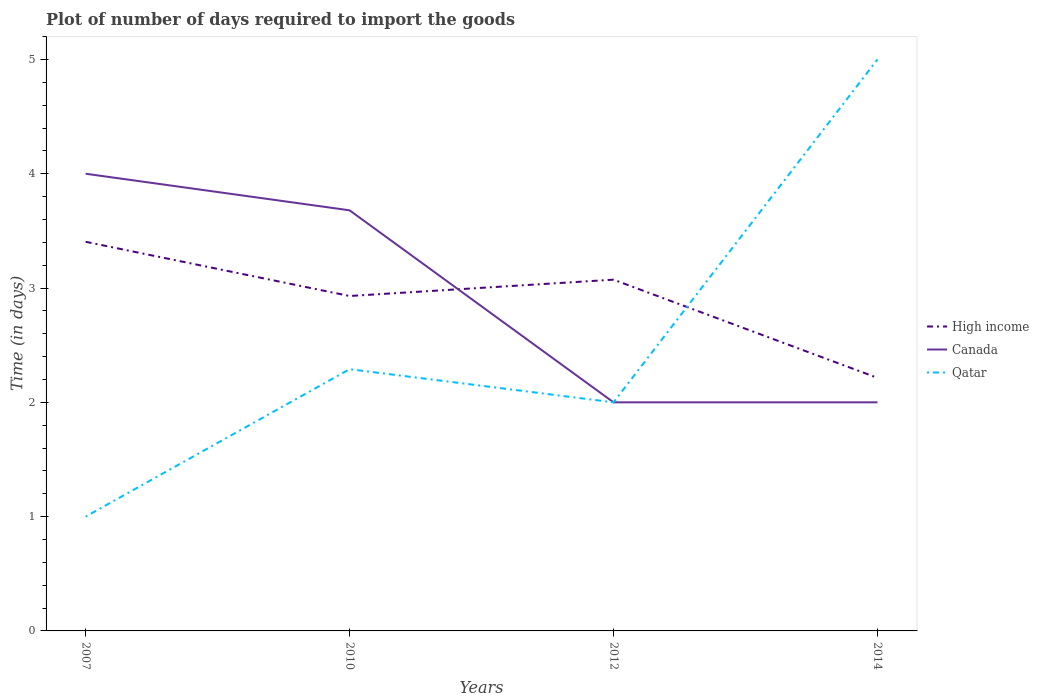Is the number of lines equal to the number of legend labels?
Provide a short and direct response. Yes. In which year was the time required to import goods in Qatar maximum?
Your answer should be compact. 2007. What is the total time required to import goods in Qatar in the graph?
Your response must be concise. -1.29. How many years are there in the graph?
Provide a succinct answer. 4. Does the graph contain grids?
Make the answer very short. No. Where does the legend appear in the graph?
Offer a terse response. Center right. How many legend labels are there?
Make the answer very short. 3. What is the title of the graph?
Give a very brief answer. Plot of number of days required to import the goods. What is the label or title of the X-axis?
Your answer should be compact. Years. What is the label or title of the Y-axis?
Make the answer very short. Time (in days). What is the Time (in days) in High income in 2007?
Provide a succinct answer. 3.4. What is the Time (in days) of Canada in 2007?
Offer a very short reply. 4. What is the Time (in days) in Qatar in 2007?
Offer a terse response. 1. What is the Time (in days) of High income in 2010?
Your response must be concise. 2.93. What is the Time (in days) in Canada in 2010?
Give a very brief answer. 3.68. What is the Time (in days) of Qatar in 2010?
Offer a very short reply. 2.29. What is the Time (in days) of High income in 2012?
Your response must be concise. 3.07. What is the Time (in days) in Canada in 2012?
Provide a short and direct response. 2. What is the Time (in days) in Qatar in 2012?
Provide a succinct answer. 2. What is the Time (in days) in High income in 2014?
Provide a short and direct response. 2.21. What is the Time (in days) of Qatar in 2014?
Your answer should be compact. 5. Across all years, what is the maximum Time (in days) in High income?
Provide a short and direct response. 3.4. Across all years, what is the maximum Time (in days) in Qatar?
Provide a succinct answer. 5. Across all years, what is the minimum Time (in days) of High income?
Offer a terse response. 2.21. Across all years, what is the minimum Time (in days) of Qatar?
Make the answer very short. 1. What is the total Time (in days) in High income in the graph?
Make the answer very short. 11.62. What is the total Time (in days) of Canada in the graph?
Offer a terse response. 11.68. What is the total Time (in days) of Qatar in the graph?
Give a very brief answer. 10.29. What is the difference between the Time (in days) in High income in 2007 and that in 2010?
Provide a short and direct response. 0.47. What is the difference between the Time (in days) of Canada in 2007 and that in 2010?
Give a very brief answer. 0.32. What is the difference between the Time (in days) of Qatar in 2007 and that in 2010?
Offer a terse response. -1.29. What is the difference between the Time (in days) of High income in 2007 and that in 2012?
Provide a short and direct response. 0.33. What is the difference between the Time (in days) in Canada in 2007 and that in 2012?
Provide a succinct answer. 2. What is the difference between the Time (in days) in High income in 2007 and that in 2014?
Offer a very short reply. 1.19. What is the difference between the Time (in days) of Canada in 2007 and that in 2014?
Make the answer very short. 2. What is the difference between the Time (in days) in High income in 2010 and that in 2012?
Your response must be concise. -0.14. What is the difference between the Time (in days) in Canada in 2010 and that in 2012?
Offer a terse response. 1.68. What is the difference between the Time (in days) in Qatar in 2010 and that in 2012?
Your answer should be compact. 0.29. What is the difference between the Time (in days) of High income in 2010 and that in 2014?
Offer a very short reply. 0.72. What is the difference between the Time (in days) of Canada in 2010 and that in 2014?
Offer a very short reply. 1.68. What is the difference between the Time (in days) of Qatar in 2010 and that in 2014?
Give a very brief answer. -2.71. What is the difference between the Time (in days) in High income in 2012 and that in 2014?
Your answer should be very brief. 0.86. What is the difference between the Time (in days) in Canada in 2012 and that in 2014?
Your response must be concise. 0. What is the difference between the Time (in days) in High income in 2007 and the Time (in days) in Canada in 2010?
Your answer should be very brief. -0.28. What is the difference between the Time (in days) of High income in 2007 and the Time (in days) of Qatar in 2010?
Give a very brief answer. 1.11. What is the difference between the Time (in days) in Canada in 2007 and the Time (in days) in Qatar in 2010?
Provide a succinct answer. 1.71. What is the difference between the Time (in days) of High income in 2007 and the Time (in days) of Canada in 2012?
Give a very brief answer. 1.4. What is the difference between the Time (in days) in High income in 2007 and the Time (in days) in Qatar in 2012?
Your answer should be compact. 1.4. What is the difference between the Time (in days) of Canada in 2007 and the Time (in days) of Qatar in 2012?
Keep it short and to the point. 2. What is the difference between the Time (in days) of High income in 2007 and the Time (in days) of Canada in 2014?
Keep it short and to the point. 1.4. What is the difference between the Time (in days) of High income in 2007 and the Time (in days) of Qatar in 2014?
Offer a terse response. -1.6. What is the difference between the Time (in days) in Canada in 2007 and the Time (in days) in Qatar in 2014?
Make the answer very short. -1. What is the difference between the Time (in days) in High income in 2010 and the Time (in days) in Canada in 2012?
Your answer should be very brief. 0.93. What is the difference between the Time (in days) of High income in 2010 and the Time (in days) of Qatar in 2012?
Ensure brevity in your answer.  0.93. What is the difference between the Time (in days) of Canada in 2010 and the Time (in days) of Qatar in 2012?
Your answer should be compact. 1.68. What is the difference between the Time (in days) in High income in 2010 and the Time (in days) in Canada in 2014?
Provide a short and direct response. 0.93. What is the difference between the Time (in days) of High income in 2010 and the Time (in days) of Qatar in 2014?
Your response must be concise. -2.07. What is the difference between the Time (in days) of Canada in 2010 and the Time (in days) of Qatar in 2014?
Give a very brief answer. -1.32. What is the difference between the Time (in days) in High income in 2012 and the Time (in days) in Canada in 2014?
Your answer should be very brief. 1.07. What is the difference between the Time (in days) in High income in 2012 and the Time (in days) in Qatar in 2014?
Provide a succinct answer. -1.93. What is the average Time (in days) of High income per year?
Offer a very short reply. 2.91. What is the average Time (in days) of Canada per year?
Your answer should be compact. 2.92. What is the average Time (in days) of Qatar per year?
Your response must be concise. 2.57. In the year 2007, what is the difference between the Time (in days) of High income and Time (in days) of Canada?
Make the answer very short. -0.6. In the year 2007, what is the difference between the Time (in days) in High income and Time (in days) in Qatar?
Your response must be concise. 2.4. In the year 2010, what is the difference between the Time (in days) in High income and Time (in days) in Canada?
Give a very brief answer. -0.75. In the year 2010, what is the difference between the Time (in days) of High income and Time (in days) of Qatar?
Offer a terse response. 0.64. In the year 2010, what is the difference between the Time (in days) of Canada and Time (in days) of Qatar?
Offer a very short reply. 1.39. In the year 2012, what is the difference between the Time (in days) in High income and Time (in days) in Canada?
Your response must be concise. 1.07. In the year 2012, what is the difference between the Time (in days) in High income and Time (in days) in Qatar?
Provide a short and direct response. 1.07. In the year 2014, what is the difference between the Time (in days) of High income and Time (in days) of Canada?
Provide a succinct answer. 0.21. In the year 2014, what is the difference between the Time (in days) of High income and Time (in days) of Qatar?
Offer a terse response. -2.79. In the year 2014, what is the difference between the Time (in days) of Canada and Time (in days) of Qatar?
Your answer should be very brief. -3. What is the ratio of the Time (in days) in High income in 2007 to that in 2010?
Offer a very short reply. 1.16. What is the ratio of the Time (in days) of Canada in 2007 to that in 2010?
Offer a very short reply. 1.09. What is the ratio of the Time (in days) in Qatar in 2007 to that in 2010?
Ensure brevity in your answer.  0.44. What is the ratio of the Time (in days) of High income in 2007 to that in 2012?
Keep it short and to the point. 1.11. What is the ratio of the Time (in days) in Canada in 2007 to that in 2012?
Your answer should be compact. 2. What is the ratio of the Time (in days) of Qatar in 2007 to that in 2012?
Make the answer very short. 0.5. What is the ratio of the Time (in days) in High income in 2007 to that in 2014?
Ensure brevity in your answer.  1.54. What is the ratio of the Time (in days) in Canada in 2007 to that in 2014?
Ensure brevity in your answer.  2. What is the ratio of the Time (in days) of High income in 2010 to that in 2012?
Provide a short and direct response. 0.95. What is the ratio of the Time (in days) in Canada in 2010 to that in 2012?
Offer a terse response. 1.84. What is the ratio of the Time (in days) in Qatar in 2010 to that in 2012?
Provide a succinct answer. 1.15. What is the ratio of the Time (in days) in High income in 2010 to that in 2014?
Your response must be concise. 1.32. What is the ratio of the Time (in days) of Canada in 2010 to that in 2014?
Your answer should be very brief. 1.84. What is the ratio of the Time (in days) in Qatar in 2010 to that in 2014?
Make the answer very short. 0.46. What is the ratio of the Time (in days) in High income in 2012 to that in 2014?
Ensure brevity in your answer.  1.39. What is the ratio of the Time (in days) of Qatar in 2012 to that in 2014?
Your answer should be compact. 0.4. What is the difference between the highest and the second highest Time (in days) of High income?
Keep it short and to the point. 0.33. What is the difference between the highest and the second highest Time (in days) in Canada?
Provide a short and direct response. 0.32. What is the difference between the highest and the second highest Time (in days) in Qatar?
Offer a very short reply. 2.71. What is the difference between the highest and the lowest Time (in days) of High income?
Make the answer very short. 1.19. What is the difference between the highest and the lowest Time (in days) in Canada?
Provide a short and direct response. 2. 